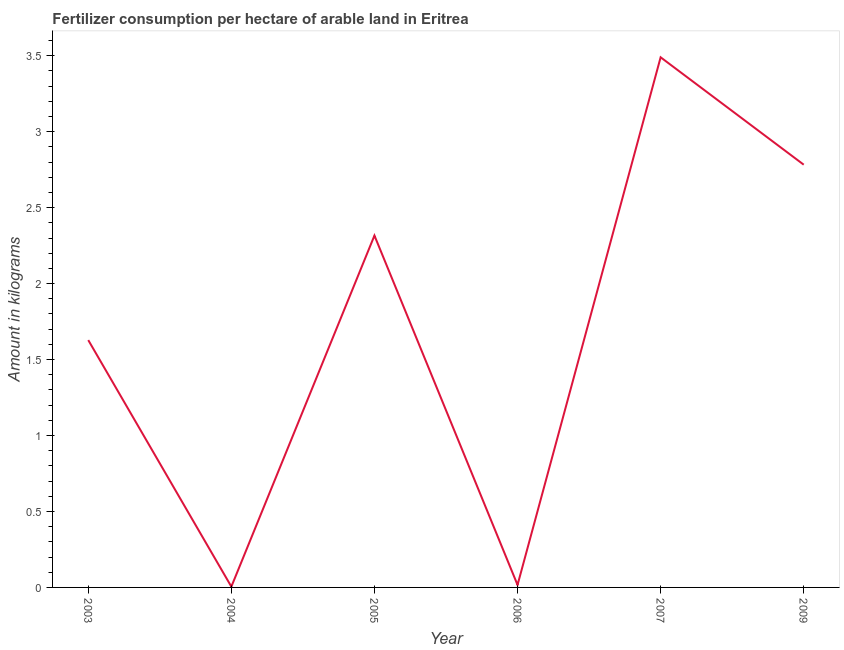What is the amount of fertilizer consumption in 2007?
Offer a very short reply. 3.49. Across all years, what is the maximum amount of fertilizer consumption?
Give a very brief answer. 3.49. Across all years, what is the minimum amount of fertilizer consumption?
Ensure brevity in your answer.  0.01. In which year was the amount of fertilizer consumption minimum?
Offer a very short reply. 2004. What is the sum of the amount of fertilizer consumption?
Keep it short and to the point. 10.24. What is the difference between the amount of fertilizer consumption in 2005 and 2009?
Offer a very short reply. -0.47. What is the average amount of fertilizer consumption per year?
Your answer should be compact. 1.71. What is the median amount of fertilizer consumption?
Ensure brevity in your answer.  1.97. In how many years, is the amount of fertilizer consumption greater than 2.7 kg?
Your answer should be very brief. 2. What is the ratio of the amount of fertilizer consumption in 2003 to that in 2006?
Make the answer very short. 99.17. Is the amount of fertilizer consumption in 2003 less than that in 2005?
Provide a succinct answer. Yes. What is the difference between the highest and the second highest amount of fertilizer consumption?
Make the answer very short. 0.71. What is the difference between the highest and the lowest amount of fertilizer consumption?
Make the answer very short. 3.48. How many years are there in the graph?
Your response must be concise. 6. Are the values on the major ticks of Y-axis written in scientific E-notation?
Provide a short and direct response. No. Does the graph contain any zero values?
Your response must be concise. No. What is the title of the graph?
Your response must be concise. Fertilizer consumption per hectare of arable land in Eritrea . What is the label or title of the X-axis?
Offer a very short reply. Year. What is the label or title of the Y-axis?
Your answer should be compact. Amount in kilograms. What is the Amount in kilograms of 2003?
Ensure brevity in your answer.  1.63. What is the Amount in kilograms of 2004?
Make the answer very short. 0.01. What is the Amount in kilograms of 2005?
Your answer should be very brief. 2.32. What is the Amount in kilograms in 2006?
Provide a short and direct response. 0.02. What is the Amount in kilograms of 2007?
Offer a very short reply. 3.49. What is the Amount in kilograms of 2009?
Provide a short and direct response. 2.78. What is the difference between the Amount in kilograms in 2003 and 2004?
Your answer should be very brief. 1.62. What is the difference between the Amount in kilograms in 2003 and 2005?
Ensure brevity in your answer.  -0.69. What is the difference between the Amount in kilograms in 2003 and 2006?
Ensure brevity in your answer.  1.61. What is the difference between the Amount in kilograms in 2003 and 2007?
Your answer should be very brief. -1.86. What is the difference between the Amount in kilograms in 2003 and 2009?
Your response must be concise. -1.15. What is the difference between the Amount in kilograms in 2004 and 2005?
Make the answer very short. -2.31. What is the difference between the Amount in kilograms in 2004 and 2006?
Provide a short and direct response. -0.01. What is the difference between the Amount in kilograms in 2004 and 2007?
Keep it short and to the point. -3.48. What is the difference between the Amount in kilograms in 2004 and 2009?
Provide a short and direct response. -2.78. What is the difference between the Amount in kilograms in 2005 and 2006?
Your answer should be compact. 2.3. What is the difference between the Amount in kilograms in 2005 and 2007?
Make the answer very short. -1.17. What is the difference between the Amount in kilograms in 2005 and 2009?
Your answer should be very brief. -0.47. What is the difference between the Amount in kilograms in 2006 and 2007?
Your answer should be compact. -3.47. What is the difference between the Amount in kilograms in 2006 and 2009?
Offer a terse response. -2.77. What is the difference between the Amount in kilograms in 2007 and 2009?
Your answer should be very brief. 0.71. What is the ratio of the Amount in kilograms in 2003 to that in 2004?
Make the answer very short. 324.54. What is the ratio of the Amount in kilograms in 2003 to that in 2005?
Provide a short and direct response. 0.7. What is the ratio of the Amount in kilograms in 2003 to that in 2006?
Your response must be concise. 99.17. What is the ratio of the Amount in kilograms in 2003 to that in 2007?
Offer a very short reply. 0.47. What is the ratio of the Amount in kilograms in 2003 to that in 2009?
Offer a very short reply. 0.58. What is the ratio of the Amount in kilograms in 2004 to that in 2005?
Provide a short and direct response. 0. What is the ratio of the Amount in kilograms in 2004 to that in 2006?
Your answer should be compact. 0.31. What is the ratio of the Amount in kilograms in 2004 to that in 2007?
Offer a very short reply. 0. What is the ratio of the Amount in kilograms in 2004 to that in 2009?
Your answer should be very brief. 0. What is the ratio of the Amount in kilograms in 2005 to that in 2006?
Your answer should be compact. 141.07. What is the ratio of the Amount in kilograms in 2005 to that in 2007?
Your answer should be compact. 0.66. What is the ratio of the Amount in kilograms in 2005 to that in 2009?
Your answer should be very brief. 0.83. What is the ratio of the Amount in kilograms in 2006 to that in 2007?
Keep it short and to the point. 0.01. What is the ratio of the Amount in kilograms in 2006 to that in 2009?
Ensure brevity in your answer.  0.01. What is the ratio of the Amount in kilograms in 2007 to that in 2009?
Your answer should be compact. 1.25. 